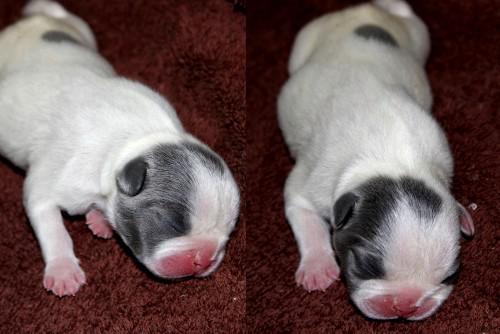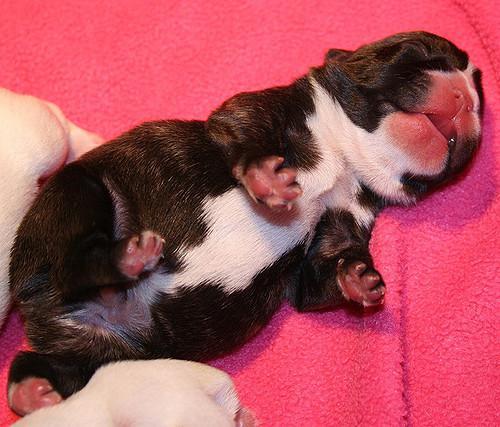The first image is the image on the left, the second image is the image on the right. For the images shown, is this caption "A human is at least partially visible in the image on the right." true? Answer yes or no. No. 